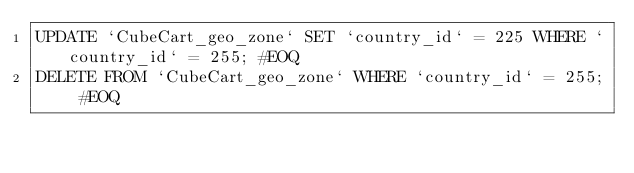<code> <loc_0><loc_0><loc_500><loc_500><_SQL_>UPDATE `CubeCart_geo_zone` SET `country_id` = 225 WHERE `country_id` = 255; #EOQ
DELETE FROM `CubeCart_geo_zone` WHERE `country_id` = 255; #EOQ</code> 